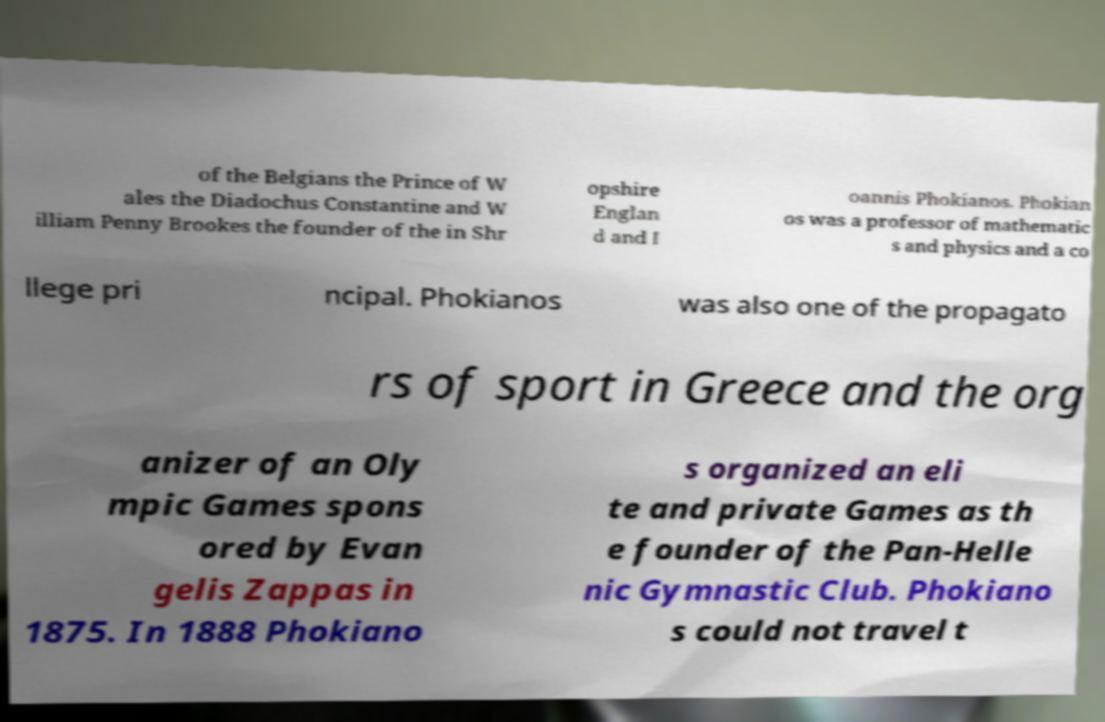What messages or text are displayed in this image? I need them in a readable, typed format. of the Belgians the Prince of W ales the Diadochus Constantine and W illiam Penny Brookes the founder of the in Shr opshire Englan d and I oannis Phokianos. Phokian os was a professor of mathematic s and physics and a co llege pri ncipal. Phokianos was also one of the propagato rs of sport in Greece and the org anizer of an Oly mpic Games spons ored by Evan gelis Zappas in 1875. In 1888 Phokiano s organized an eli te and private Games as th e founder of the Pan-Helle nic Gymnastic Club. Phokiano s could not travel t 